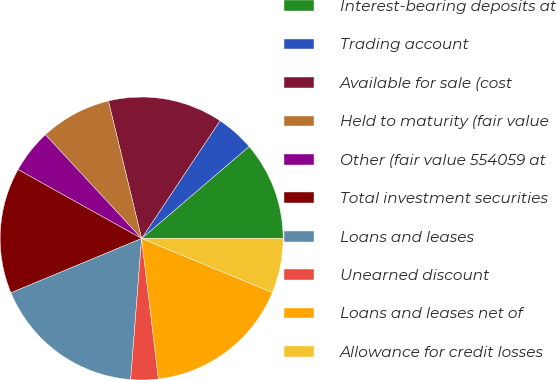Convert chart. <chart><loc_0><loc_0><loc_500><loc_500><pie_chart><fcel>Interest-bearing deposits at<fcel>Trading account<fcel>Available for sale (cost<fcel>Held to maturity (fair value<fcel>Other (fair value 554059 at<fcel>Total investment securities<fcel>Loans and leases<fcel>Unearned discount<fcel>Loans and leases net of<fcel>Allowance for credit losses<nl><fcel>11.25%<fcel>4.38%<fcel>13.12%<fcel>8.13%<fcel>5.0%<fcel>14.37%<fcel>17.5%<fcel>3.13%<fcel>16.87%<fcel>6.25%<nl></chart> 